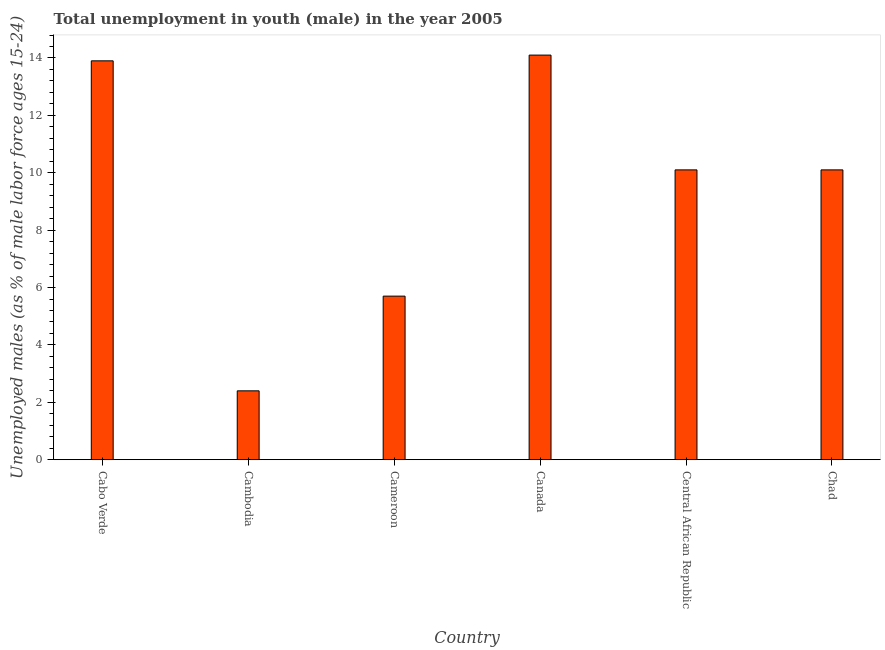Does the graph contain grids?
Ensure brevity in your answer.  No. What is the title of the graph?
Provide a succinct answer. Total unemployment in youth (male) in the year 2005. What is the label or title of the X-axis?
Make the answer very short. Country. What is the label or title of the Y-axis?
Provide a succinct answer. Unemployed males (as % of male labor force ages 15-24). What is the unemployed male youth population in Chad?
Your answer should be compact. 10.1. Across all countries, what is the maximum unemployed male youth population?
Ensure brevity in your answer.  14.1. Across all countries, what is the minimum unemployed male youth population?
Offer a very short reply. 2.4. In which country was the unemployed male youth population minimum?
Provide a succinct answer. Cambodia. What is the sum of the unemployed male youth population?
Keep it short and to the point. 56.3. What is the average unemployed male youth population per country?
Offer a terse response. 9.38. What is the median unemployed male youth population?
Ensure brevity in your answer.  10.1. What is the ratio of the unemployed male youth population in Cabo Verde to that in Cameroon?
Give a very brief answer. 2.44. Is the unemployed male youth population in Cabo Verde less than that in Canada?
Offer a terse response. Yes. Is the difference between the unemployed male youth population in Cameroon and Chad greater than the difference between any two countries?
Offer a terse response. No. What is the difference between the highest and the second highest unemployed male youth population?
Your response must be concise. 0.2. Is the sum of the unemployed male youth population in Cameroon and Chad greater than the maximum unemployed male youth population across all countries?
Offer a terse response. Yes. In how many countries, is the unemployed male youth population greater than the average unemployed male youth population taken over all countries?
Provide a succinct answer. 4. How many bars are there?
Offer a very short reply. 6. What is the Unemployed males (as % of male labor force ages 15-24) of Cabo Verde?
Your answer should be very brief. 13.9. What is the Unemployed males (as % of male labor force ages 15-24) in Cambodia?
Offer a very short reply. 2.4. What is the Unemployed males (as % of male labor force ages 15-24) in Cameroon?
Your answer should be compact. 5.7. What is the Unemployed males (as % of male labor force ages 15-24) in Canada?
Provide a short and direct response. 14.1. What is the Unemployed males (as % of male labor force ages 15-24) in Central African Republic?
Your answer should be very brief. 10.1. What is the Unemployed males (as % of male labor force ages 15-24) of Chad?
Give a very brief answer. 10.1. What is the difference between the Unemployed males (as % of male labor force ages 15-24) in Cabo Verde and Cambodia?
Your answer should be compact. 11.5. What is the difference between the Unemployed males (as % of male labor force ages 15-24) in Cabo Verde and Chad?
Give a very brief answer. 3.8. What is the difference between the Unemployed males (as % of male labor force ages 15-24) in Cambodia and Chad?
Your answer should be very brief. -7.7. What is the difference between the Unemployed males (as % of male labor force ages 15-24) in Cameroon and Central African Republic?
Your answer should be very brief. -4.4. What is the difference between the Unemployed males (as % of male labor force ages 15-24) in Canada and Central African Republic?
Make the answer very short. 4. What is the difference between the Unemployed males (as % of male labor force ages 15-24) in Canada and Chad?
Provide a succinct answer. 4. What is the ratio of the Unemployed males (as % of male labor force ages 15-24) in Cabo Verde to that in Cambodia?
Offer a very short reply. 5.79. What is the ratio of the Unemployed males (as % of male labor force ages 15-24) in Cabo Verde to that in Cameroon?
Ensure brevity in your answer.  2.44. What is the ratio of the Unemployed males (as % of male labor force ages 15-24) in Cabo Verde to that in Central African Republic?
Ensure brevity in your answer.  1.38. What is the ratio of the Unemployed males (as % of male labor force ages 15-24) in Cabo Verde to that in Chad?
Your answer should be compact. 1.38. What is the ratio of the Unemployed males (as % of male labor force ages 15-24) in Cambodia to that in Cameroon?
Your response must be concise. 0.42. What is the ratio of the Unemployed males (as % of male labor force ages 15-24) in Cambodia to that in Canada?
Ensure brevity in your answer.  0.17. What is the ratio of the Unemployed males (as % of male labor force ages 15-24) in Cambodia to that in Central African Republic?
Your answer should be very brief. 0.24. What is the ratio of the Unemployed males (as % of male labor force ages 15-24) in Cambodia to that in Chad?
Give a very brief answer. 0.24. What is the ratio of the Unemployed males (as % of male labor force ages 15-24) in Cameroon to that in Canada?
Offer a very short reply. 0.4. What is the ratio of the Unemployed males (as % of male labor force ages 15-24) in Cameroon to that in Central African Republic?
Offer a terse response. 0.56. What is the ratio of the Unemployed males (as % of male labor force ages 15-24) in Cameroon to that in Chad?
Your answer should be compact. 0.56. What is the ratio of the Unemployed males (as % of male labor force ages 15-24) in Canada to that in Central African Republic?
Your answer should be compact. 1.4. What is the ratio of the Unemployed males (as % of male labor force ages 15-24) in Canada to that in Chad?
Ensure brevity in your answer.  1.4. What is the ratio of the Unemployed males (as % of male labor force ages 15-24) in Central African Republic to that in Chad?
Your response must be concise. 1. 